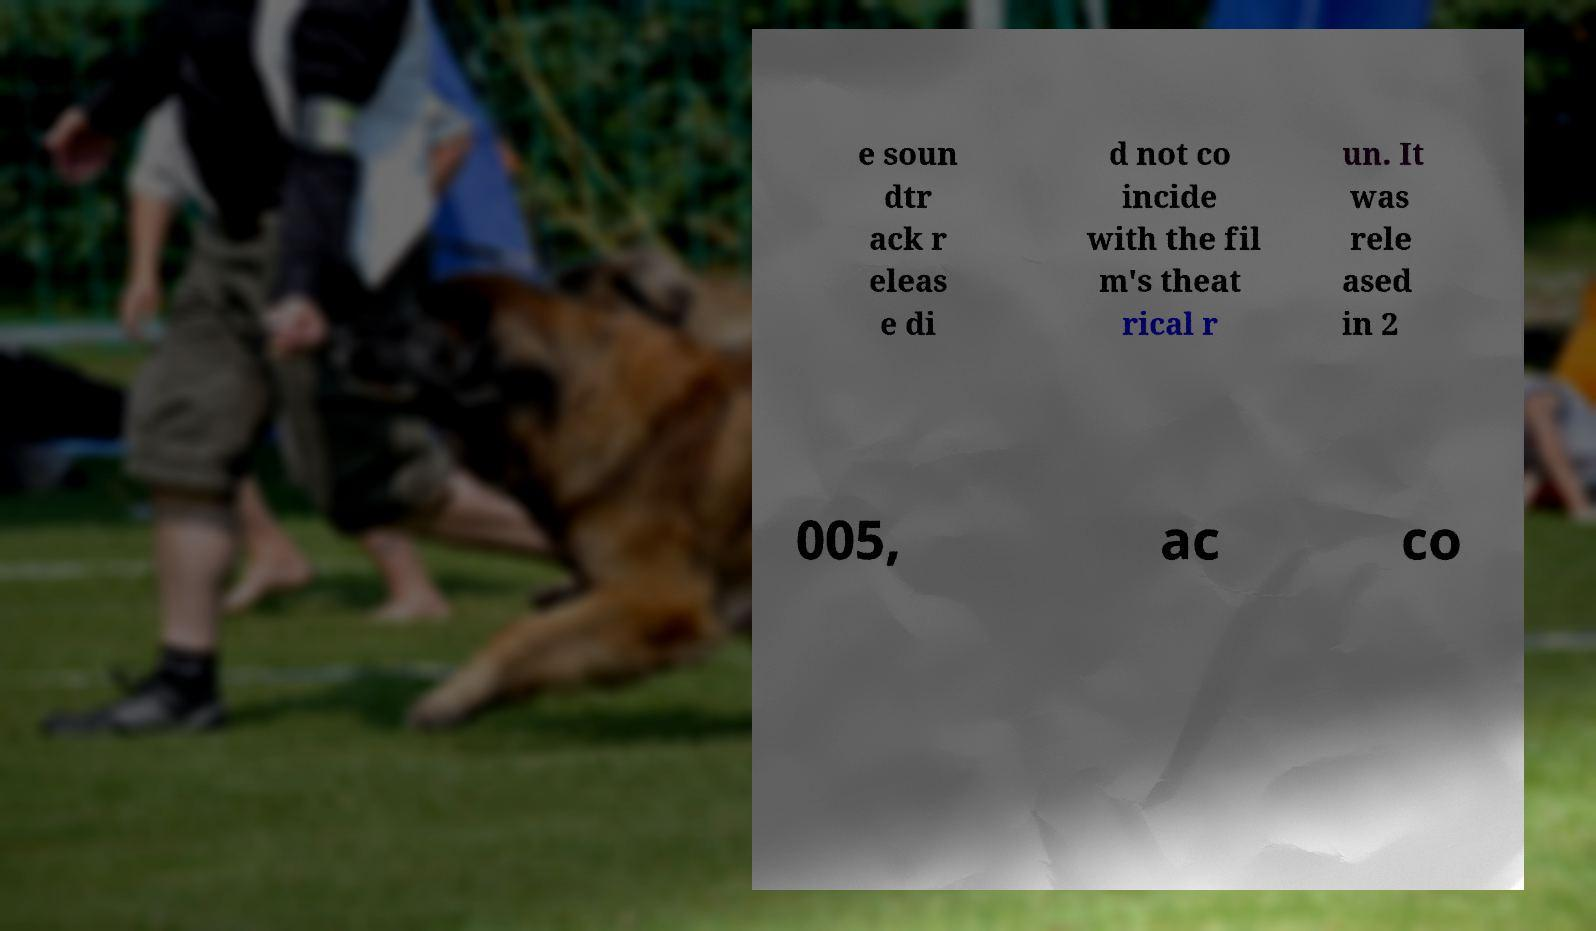Can you accurately transcribe the text from the provided image for me? e soun dtr ack r eleas e di d not co incide with the fil m's theat rical r un. It was rele ased in 2 005, ac co 